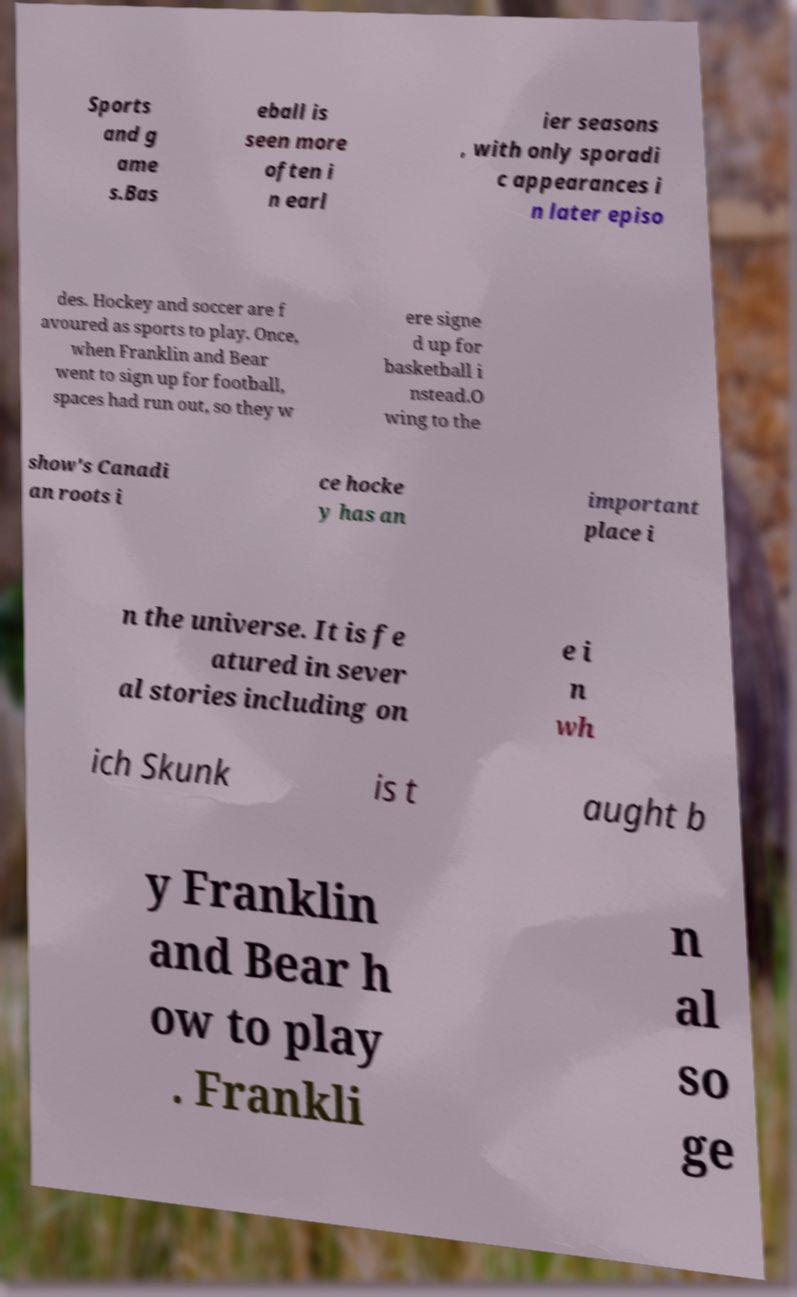Can you read and provide the text displayed in the image?This photo seems to have some interesting text. Can you extract and type it out for me? Sports and g ame s.Bas eball is seen more often i n earl ier seasons , with only sporadi c appearances i n later episo des. Hockey and soccer are f avoured as sports to play. Once, when Franklin and Bear went to sign up for football, spaces had run out, so they w ere signe d up for basketball i nstead.O wing to the show's Canadi an roots i ce hocke y has an important place i n the universe. It is fe atured in sever al stories including on e i n wh ich Skunk is t aught b y Franklin and Bear h ow to play . Frankli n al so ge 